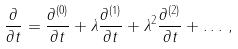Convert formula to latex. <formula><loc_0><loc_0><loc_500><loc_500>\frac { \partial } { \partial t } = \frac { \partial ^ { ( 0 ) } } { \partial t } + \lambda \frac { \partial ^ { ( 1 ) } } { \partial t } + \lambda ^ { 2 } \frac { \partial ^ { ( 2 ) } } { \partial t } + \dots \, ,</formula> 